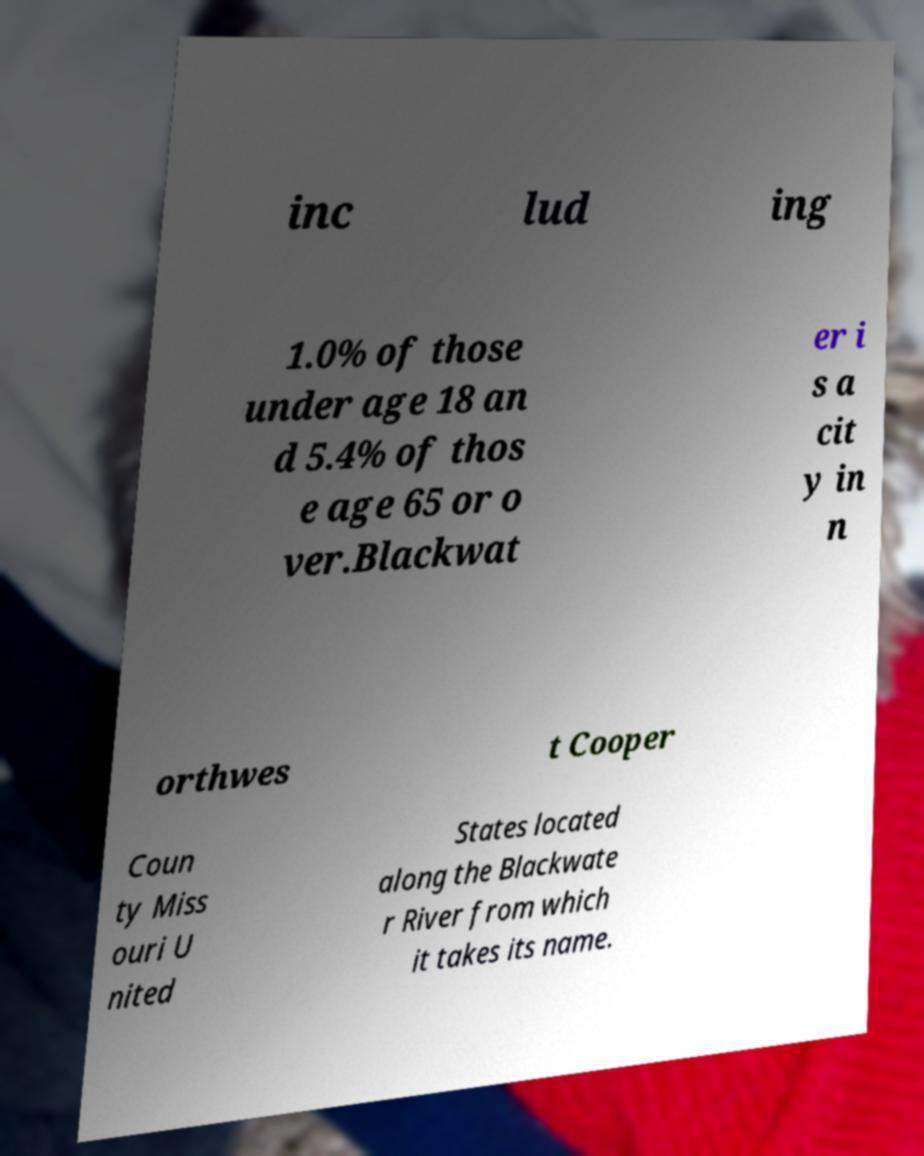Can you accurately transcribe the text from the provided image for me? inc lud ing 1.0% of those under age 18 an d 5.4% of thos e age 65 or o ver.Blackwat er i s a cit y in n orthwes t Cooper Coun ty Miss ouri U nited States located along the Blackwate r River from which it takes its name. 